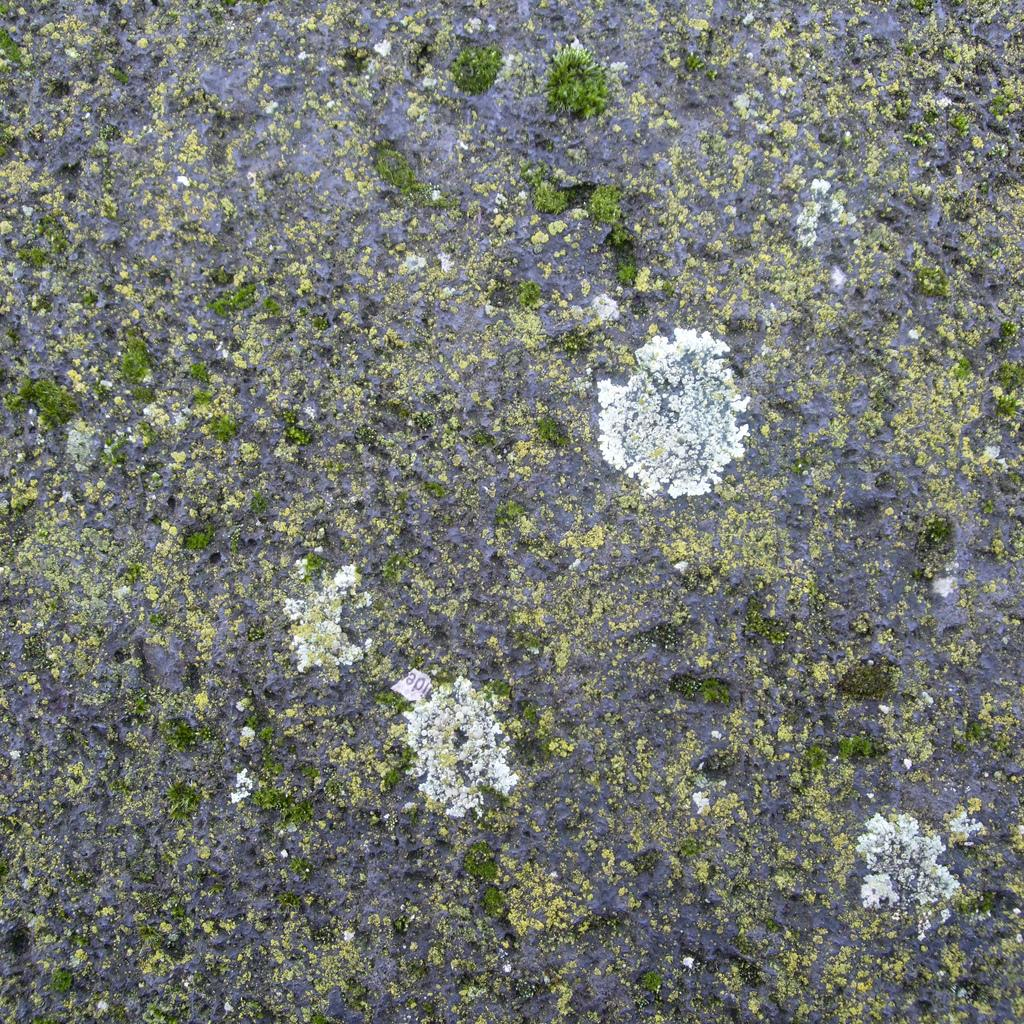What type of organism can be seen in the image? There is algae in the image. What colors are present in the algae? The algae is green and white in color. What type of shoes can be seen in the image? There are no shoes present in the image; it features algae. What material is the copper used for in the image? There is no copper present in the image. 